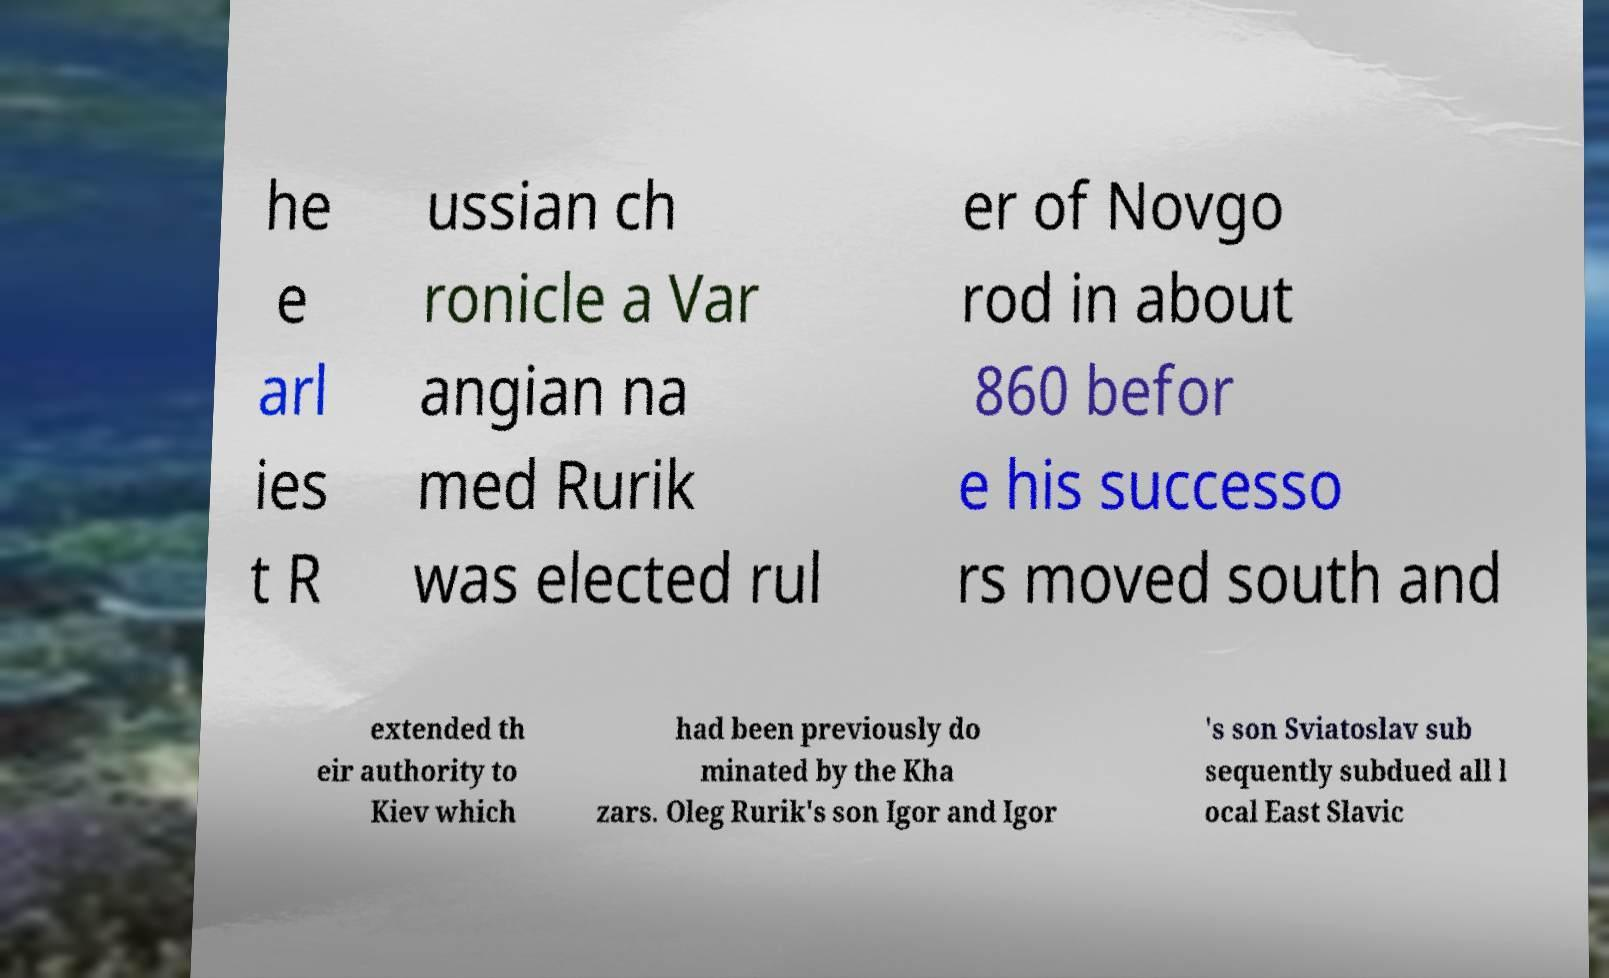Could you extract and type out the text from this image? he e arl ies t R ussian ch ronicle a Var angian na med Rurik was elected rul er of Novgo rod in about 860 befor e his successo rs moved south and extended th eir authority to Kiev which had been previously do minated by the Kha zars. Oleg Rurik's son Igor and Igor 's son Sviatoslav sub sequently subdued all l ocal East Slavic 